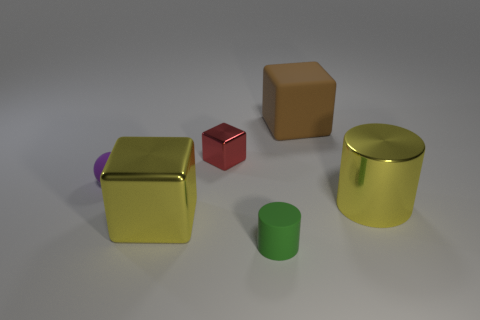What size is the metallic cylinder that is the same color as the big shiny block?
Provide a succinct answer. Large. How many blocks are either tiny metal things or large brown things?
Keep it short and to the point. 2. There is a object in front of the yellow block; does it have the same shape as the brown thing?
Provide a succinct answer. No. Is the number of purple balls that are in front of the tiny purple ball greater than the number of tiny gray things?
Offer a very short reply. No. There is a rubber thing that is the same size as the yellow shiny cylinder; what is its color?
Offer a very short reply. Brown. What number of objects are large yellow metallic things to the right of the small shiny cube or green spheres?
Your answer should be compact. 1. There is a large thing that is the same color as the big shiny cylinder; what is its shape?
Offer a very short reply. Cube. There is a big brown cube behind the tiny thing that is in front of the tiny purple object; what is its material?
Offer a terse response. Rubber. Is there a small blue ball that has the same material as the tiny block?
Ensure brevity in your answer.  No. Are there any big rubber things in front of the rubber object on the right side of the small rubber cylinder?
Provide a succinct answer. No. 